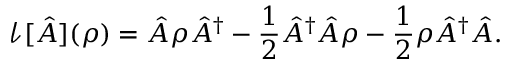Convert formula to latex. <formula><loc_0><loc_0><loc_500><loc_500>\mathcal { l } [ \hat { A } ] ( \rho ) = \hat { A } \rho \hat { A } ^ { \dagger } - \frac { 1 } { 2 } \hat { A } ^ { \dagger } \hat { A } \rho - \frac { 1 } { 2 } \rho \hat { A } ^ { \dagger } \hat { A } .</formula> 